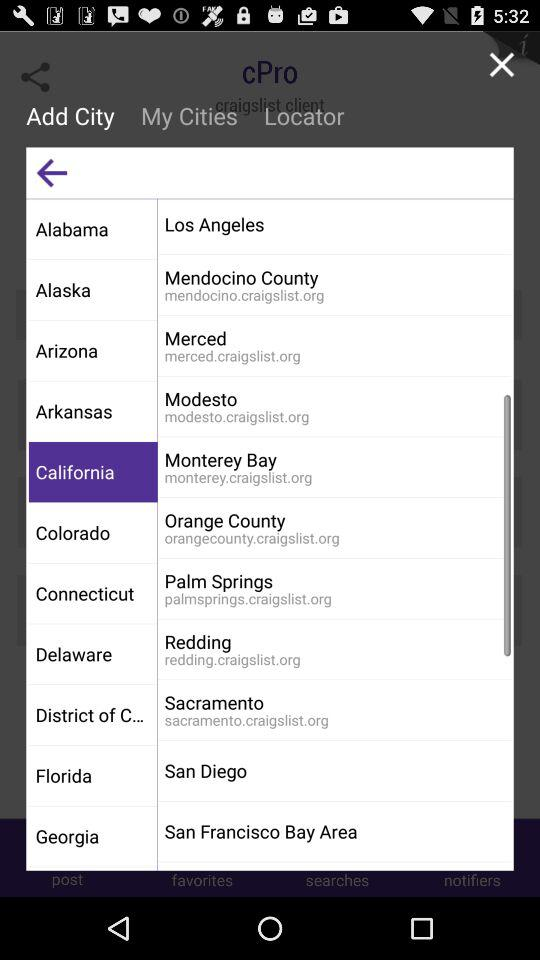Which tab is currently selected? The currently selected tab is "California". 